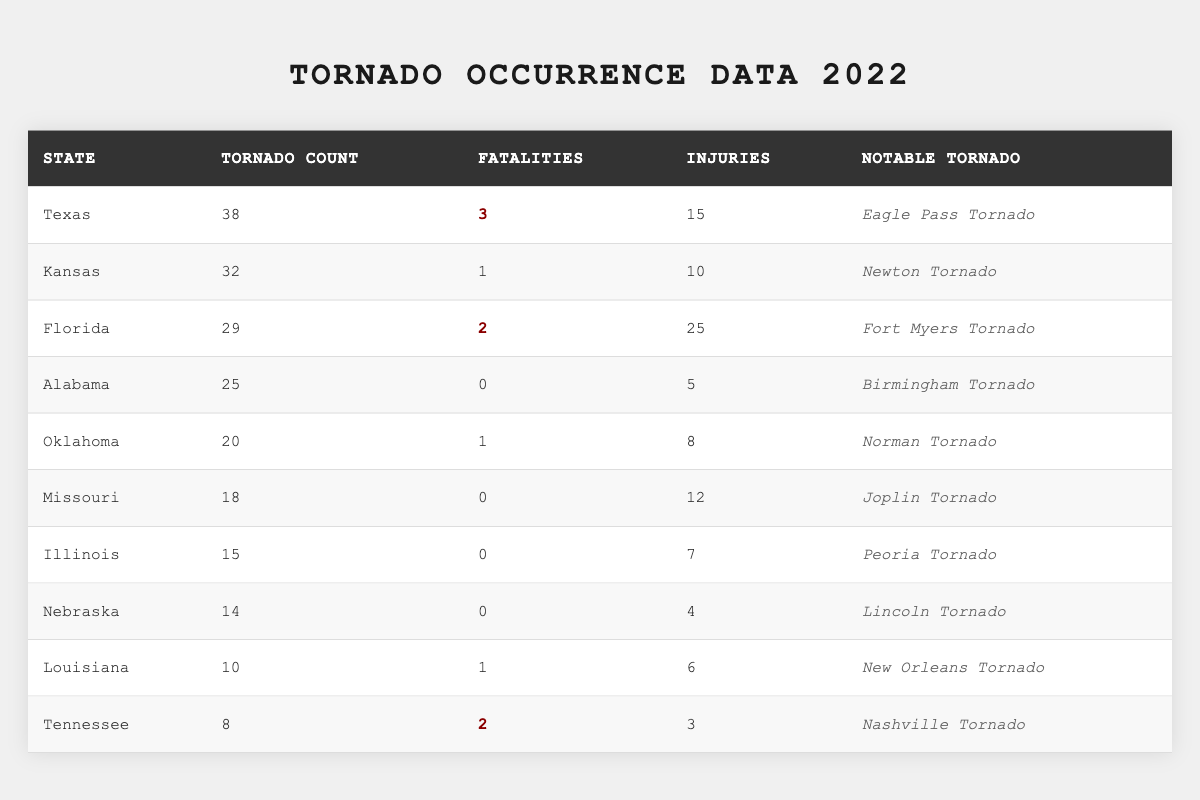What state had the highest number of tornadoes in 2022? According to the table, Texas had the highest count with 38 tornadoes.
Answer: Texas How many fatalities were reported in Florida due to tornadoes in 2022? The table indicates that Florida had 2 fatalities from tornadoes.
Answer: 2 Which state had the most injuries resulting from tornadoes in 2022? The table shows that Florida had the highest number of injuries, with 25 reported cases.
Answer: Florida What is the total number of tornadoes reported in Oklahoma and Alabama combined? Oklahoma had 20 tornadoes and Alabama had 25 tornadoes. Adding these together: 20 + 25 = 45.
Answer: 45 How many states recorded no fatalities from tornadoes in 2022? By examining the table, Alabama, Missouri, Illinois, and Nebraska all reported 0 fatalities. Therefore, there are 4 states with no fatalities.
Answer: 4 Was there any notable tornado reported from Kansas? The table lists the notable tornado for Kansas as the Newton Tornado.
Answer: Yes Which state had the least number of tornado occurrences in 2022? Louisiana had the least number with only 10 tornado occurrences as per the data.
Answer: Louisiana What is the average number of tornadoes reported across all states listed? The total number of tornadoes is 38 (Texas) + 32 (Kansas) + 29 (Florida) + 25 (Alabama) + 20 (Oklahoma) + 18 (Missouri) + 15 (Illinois) + 14 (Nebraska) + 10 (Louisiana) + 8 (Tennessee) =  288. There are 10 states, so the average is 288/10 = 28.8.
Answer: 28.8 How many tornadoes did Texas have compared to the total reported for Nebraska and Illinois combined? Texas had 38 tornadoes. Nebraska had 14 and Illinois had 15. Combined, Nebraska and Illinois had 14 + 15 = 29 tornadoes. Comparing these: 38 (Texas) vs. 29 (Nebraska and Illinois) means Texas had more.
Answer: Yes, Texas had more tornadoes Is the Eagle Pass Tornado the only notable tornado to have fatalities associated with it? The table indicates that the Eagle Pass Tornado in Texas had fatalities, but other notable tornadoes, such as the Fort Myers Tornado in Florida and the Nashville Tornado in Tennessee, also had fatalities.
Answer: No 